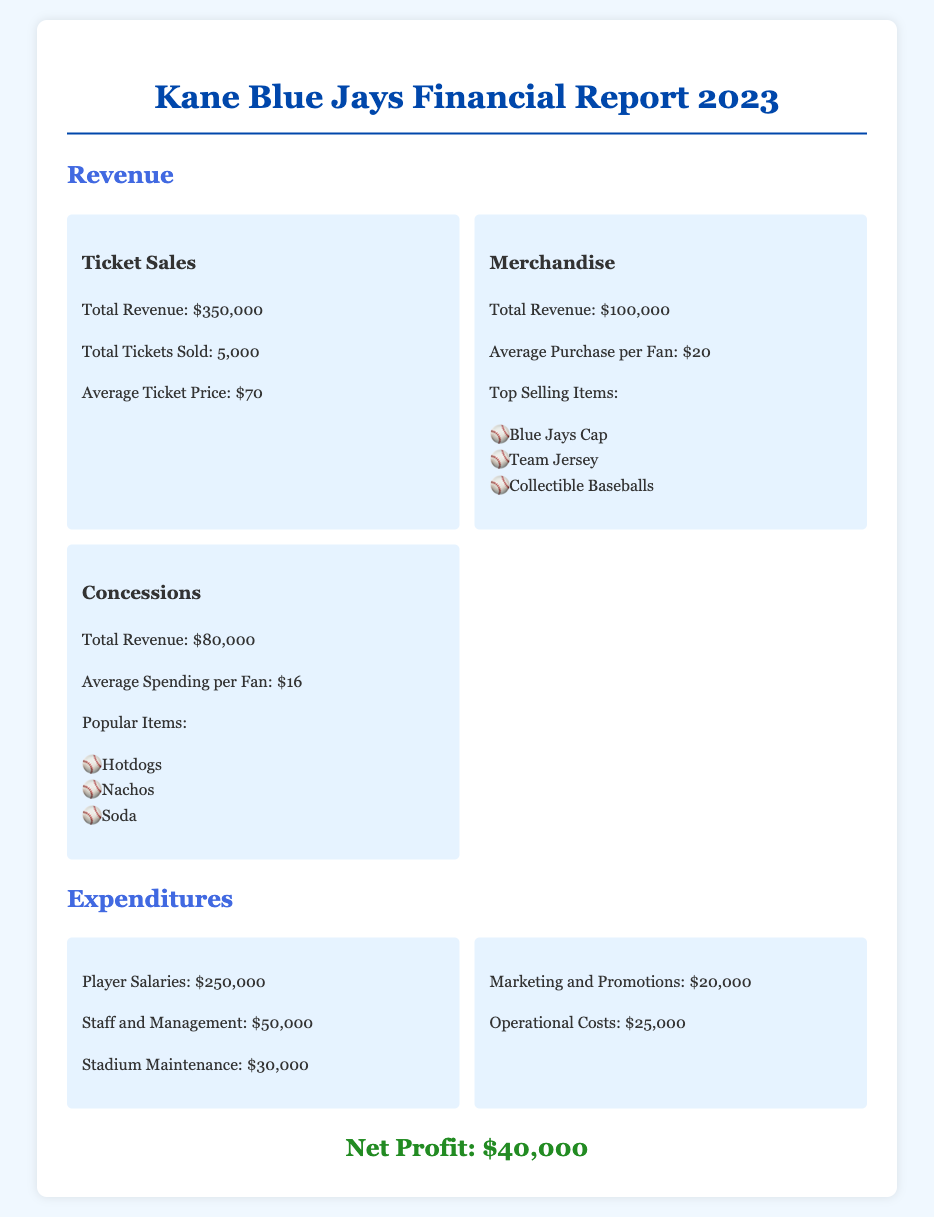what was the total revenue from ticket sales? The total revenue from ticket sales is specified in the revenue section of the document.
Answer: $350,000 how many tickets were sold? The document lists the total tickets sold in the revenue section.
Answer: 5,000 what is the average ticket price? The average ticket price is provided in the ticket sales section of the document.
Answer: $70 what was the total expenditure on player salaries? The total expenditure on player salaries is detailed in the expenditures section of the document.
Answer: $250,000 what is the net profit? The net profit is summarized at the end of the document, showing the financial outcome of the season.
Answer: $40,000 which merchandise item was the top seller? The document lists the top-selling merchandise items in the merchandise revenue section.
Answer: Blue Jays Cap what was the popular concession item? Popular items are listed in the concessions revenue section of the document.
Answer: Hotdogs how much was spent on marketing and promotions? The amount spent on marketing and promotions is specified in the expenditures section.
Answer: $20,000 what was the average spending per fan on concessions? The average spending per fan on concessions is detailed in the concessions revenue section.
Answer: $16 